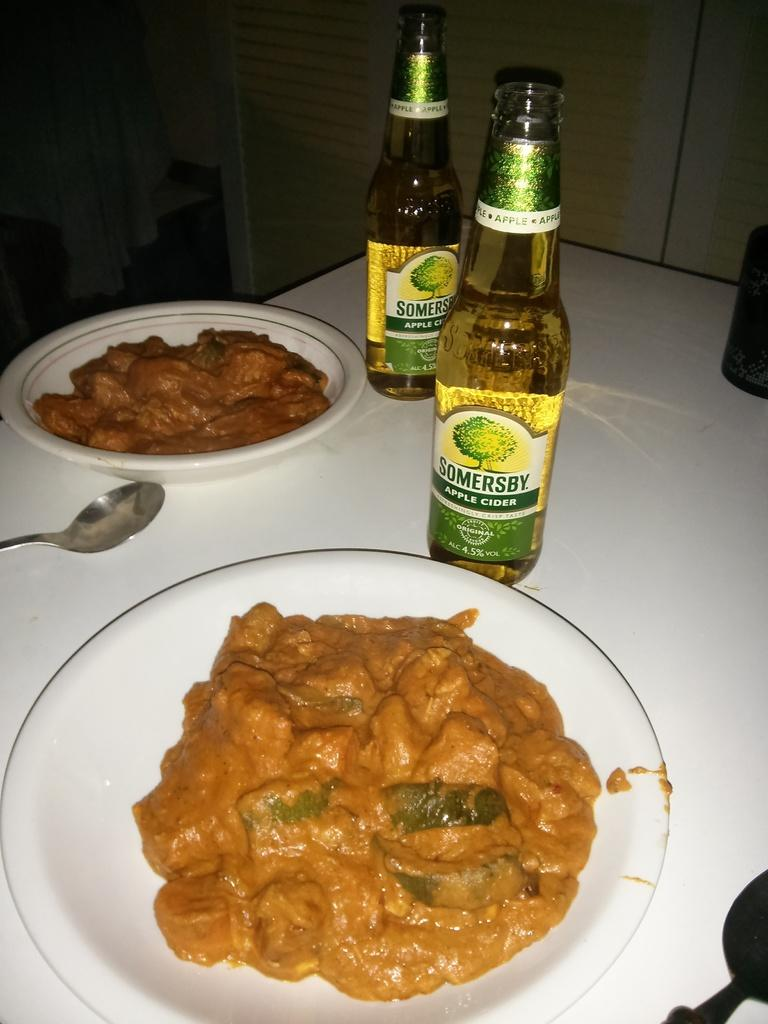Provide a one-sentence caption for the provided image. Two bottles of Somersby Apple cider are on a table with bowls of food. 